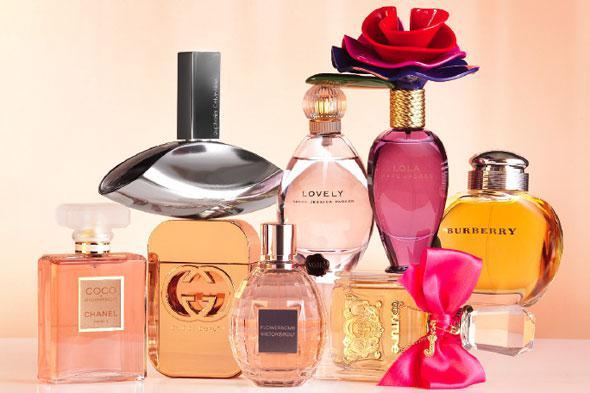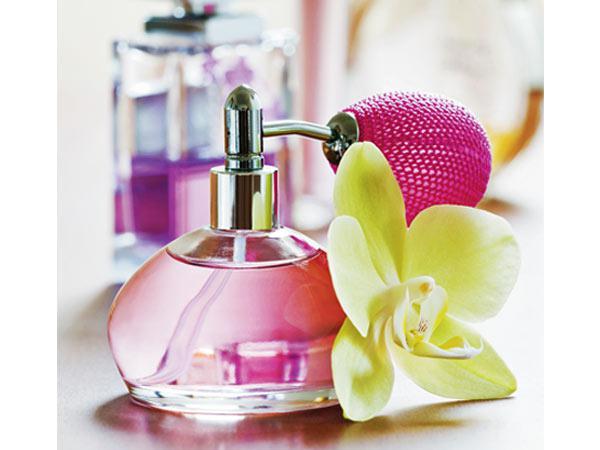The first image is the image on the left, the second image is the image on the right. Examine the images to the left and right. Is the description "In one of the images, there is no lettering on any of the perfume bottles." accurate? Answer yes or no. Yes. The first image is the image on the left, the second image is the image on the right. Examine the images to the left and right. Is the description "One image contains eight fragrance bottles in various shapes and colors, including one purplish bottle topped with a rose shape." accurate? Answer yes or no. Yes. 